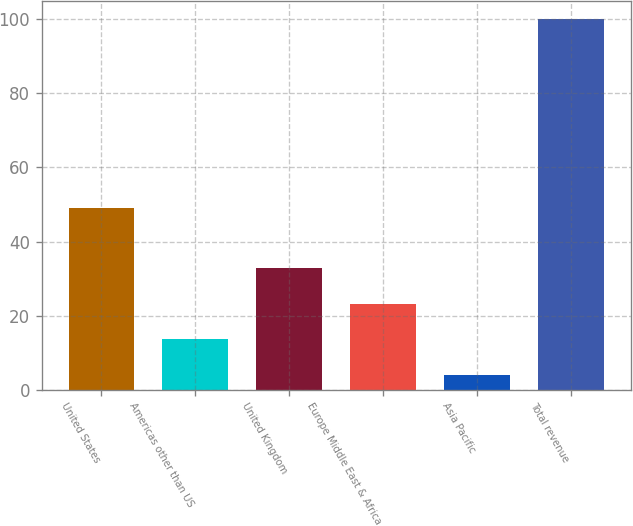Convert chart. <chart><loc_0><loc_0><loc_500><loc_500><bar_chart><fcel>United States<fcel>Americas other than US<fcel>United Kingdom<fcel>Europe Middle East & Africa<fcel>Asia Pacific<fcel>Total revenue<nl><fcel>49<fcel>13.6<fcel>32.8<fcel>23.2<fcel>4<fcel>100<nl></chart> 